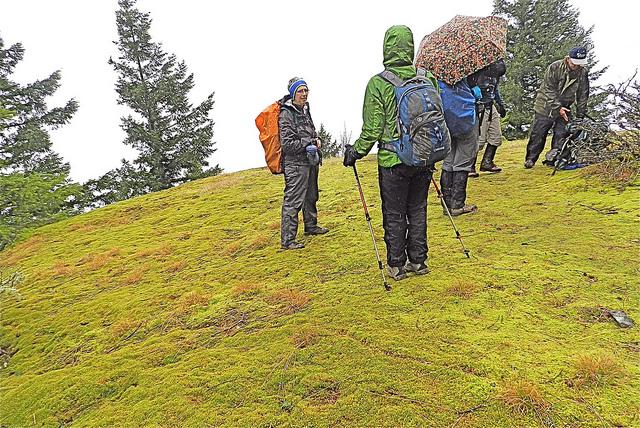How many trees are shown?
Give a very brief answer. 3. Why are the men wearing helmets?
Concise answer only. Safety. How many people are in the photo?
Keep it brief. 5. What color shirt is the man standing in the background wearing?
Write a very short answer. Black. How is the weather in this picture?
Quick response, please. Rainy. 